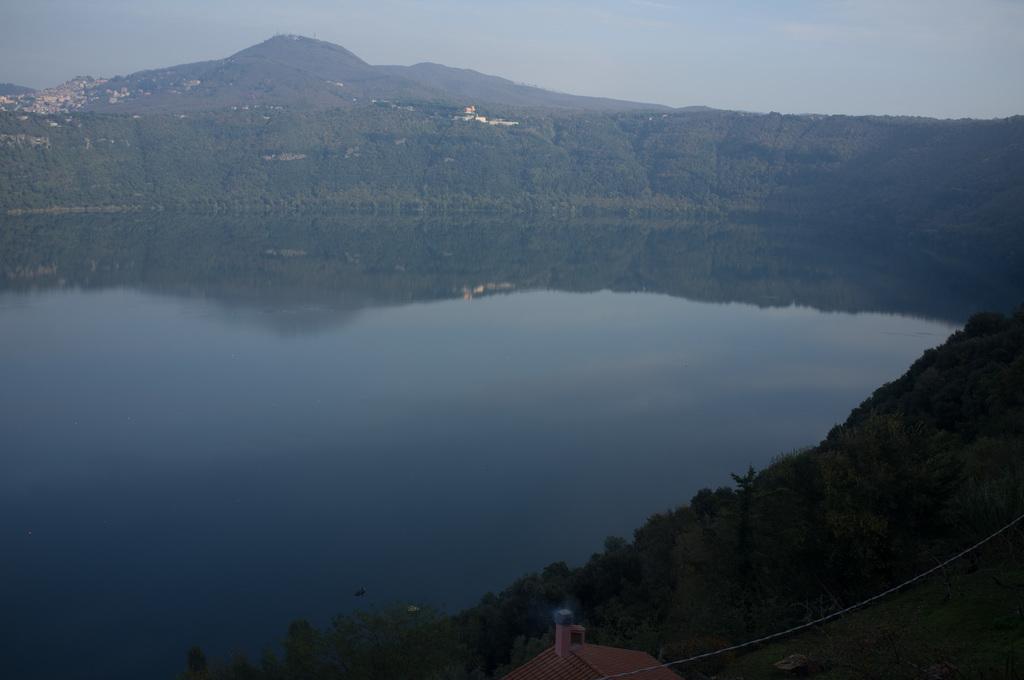In one or two sentences, can you explain what this image depicts? In this picture I can see trees and buildings and I can see hill and water and I can see a blue cloudy sky. 